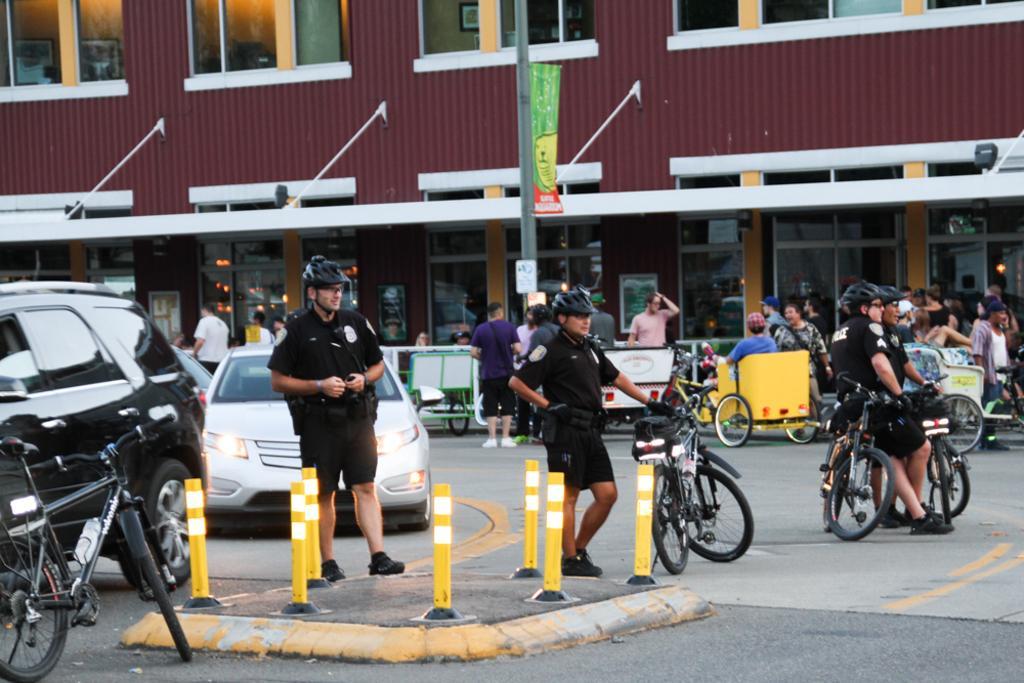Describe this image in one or two sentences. In the center of the image we can see a few vehicles on the road. And we can see a few people are standing, two persons are sitting in the vehicle and they are in different costumes. Among them, we can see a few people are wearing helmets, few people are wearing caps and a few people are holding some objects. In the background there is a building, windows, lights, sign boards, poles, one banner and a few other objects. 